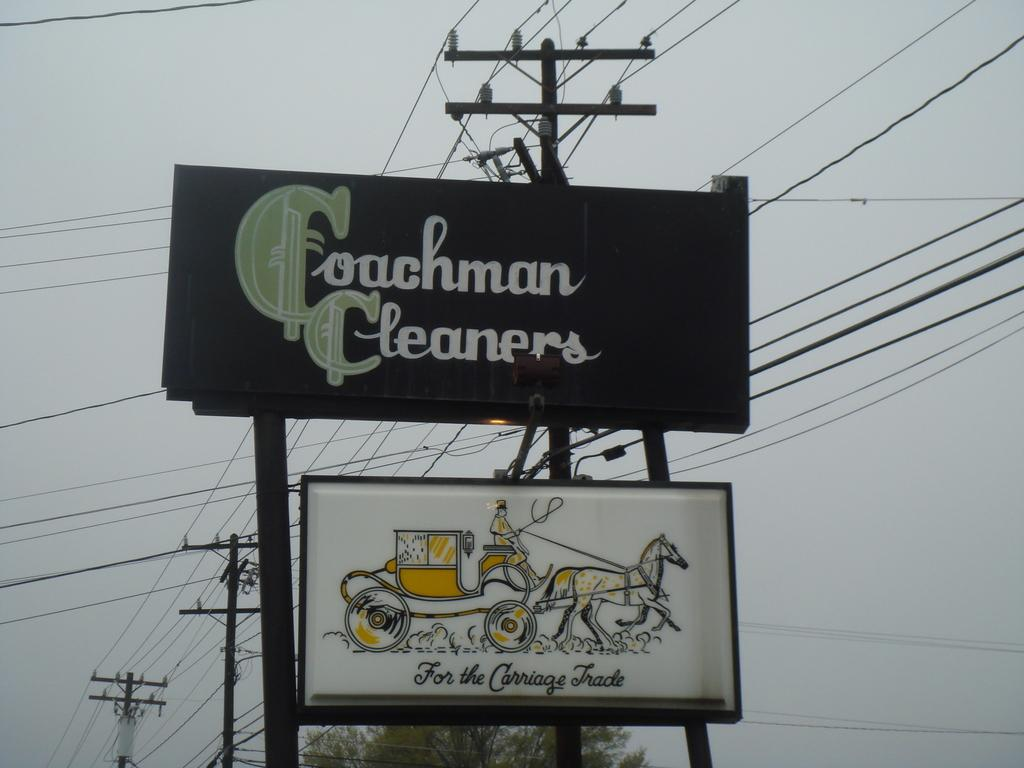Provide a one-sentence caption for the provided image. Coachman cleaners sign is prominently displayed above a sign with a horse and carriage. 